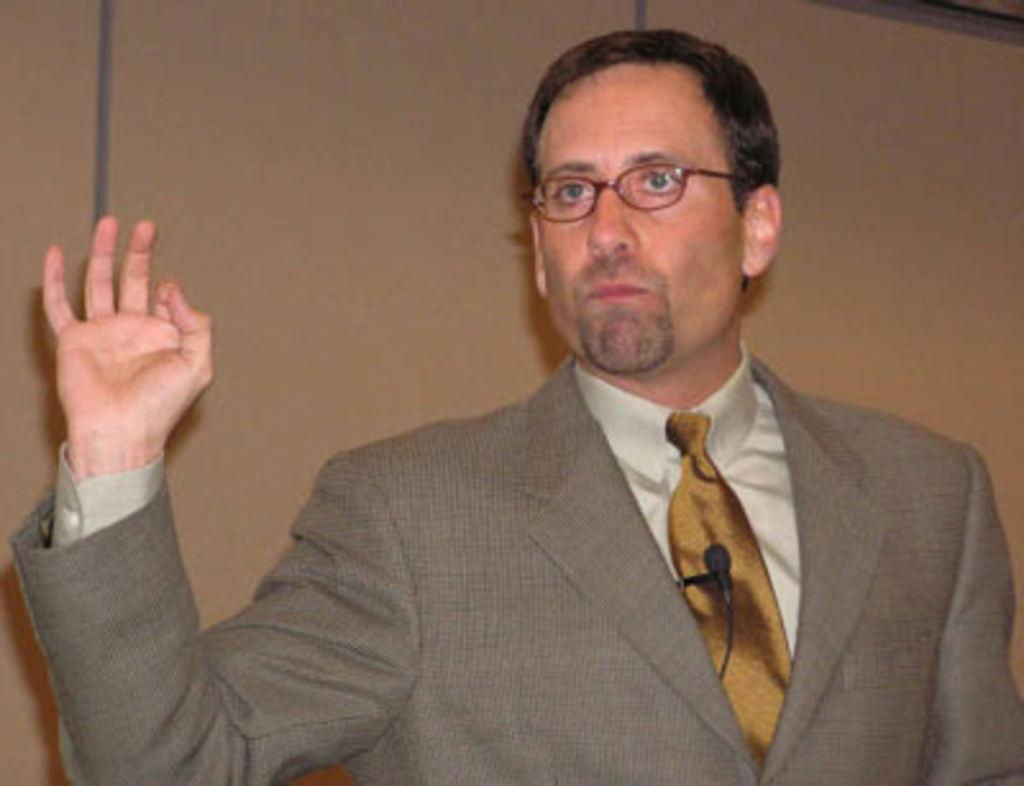What is the main subject of the image? There is a person standing in the image. Can you describe the person's appearance? The person is wearing spectacles. What object is visible near the person? There is a microphone in the image. What else can be seen in the image? There is a wire in the image. What is visible in the background of the image? There is a wall in the background of the image. What song is the person singing in the image? There is no indication in the image that the person is singing, nor is there any information about a song. 